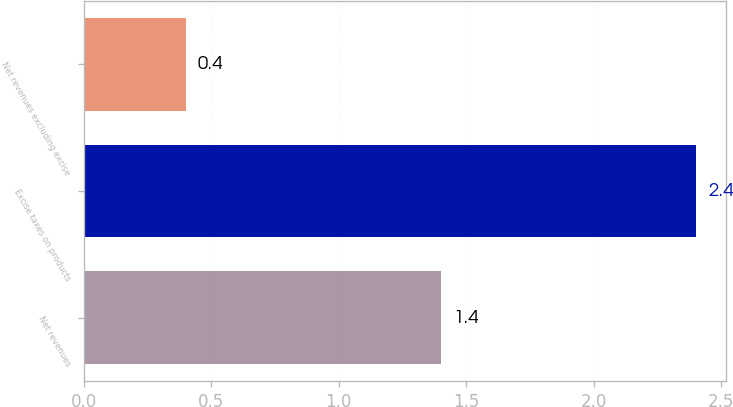Convert chart. <chart><loc_0><loc_0><loc_500><loc_500><bar_chart><fcel>Net revenues<fcel>Excise taxes on products<fcel>Net revenues excluding excise<nl><fcel>1.4<fcel>2.4<fcel>0.4<nl></chart> 